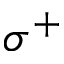<formula> <loc_0><loc_0><loc_500><loc_500>\sigma ^ { + }</formula> 